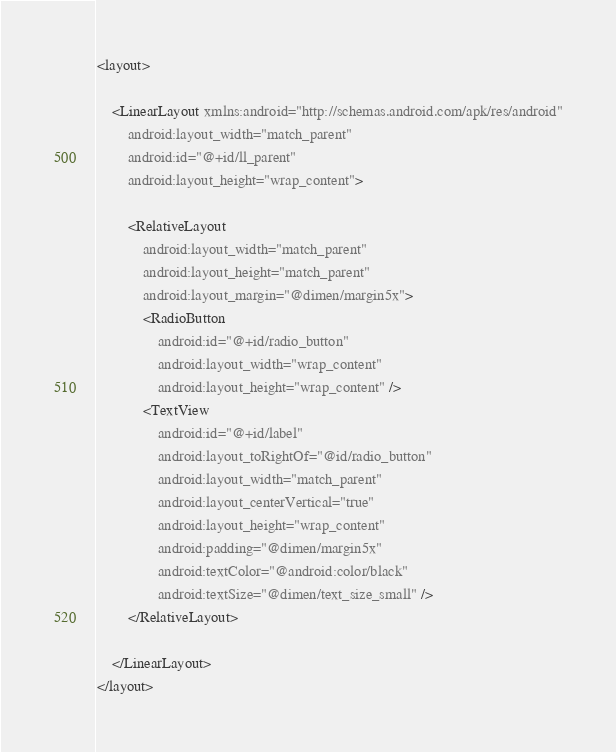<code> <loc_0><loc_0><loc_500><loc_500><_XML_><layout>

    <LinearLayout xmlns:android="http://schemas.android.com/apk/res/android"
        android:layout_width="match_parent"
        android:id="@+id/ll_parent"
        android:layout_height="wrap_content">

        <RelativeLayout
            android:layout_width="match_parent"
            android:layout_height="match_parent"
            android:layout_margin="@dimen/margin5x">
            <RadioButton
                android:id="@+id/radio_button"
                android:layout_width="wrap_content"
                android:layout_height="wrap_content" />
            <TextView
                android:id="@+id/label"
                android:layout_toRightOf="@id/radio_button"
                android:layout_width="match_parent"
                android:layout_centerVertical="true"
                android:layout_height="wrap_content"
                android:padding="@dimen/margin5x"
                android:textColor="@android:color/black"
                android:textSize="@dimen/text_size_small" />
        </RelativeLayout>

    </LinearLayout>
</layout>
</code> 